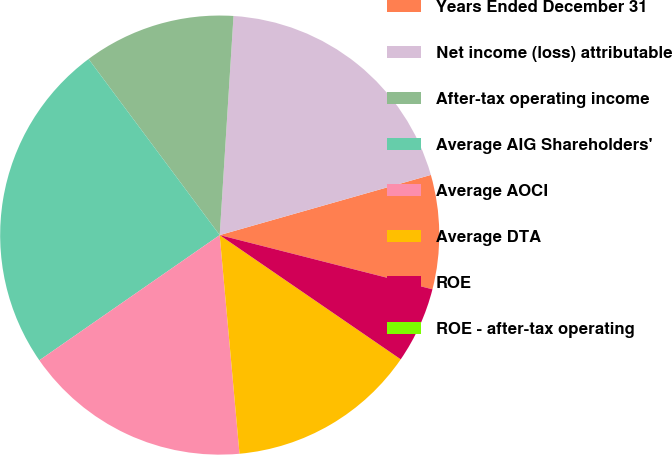<chart> <loc_0><loc_0><loc_500><loc_500><pie_chart><fcel>Years Ended December 31<fcel>Net income (loss) attributable<fcel>After-tax operating income<fcel>Average AIG Shareholders'<fcel>Average AOCI<fcel>Average DTA<fcel>ROE<fcel>ROE - after-tax operating<nl><fcel>8.39%<fcel>19.58%<fcel>11.19%<fcel>24.47%<fcel>16.78%<fcel>13.99%<fcel>5.6%<fcel>0.0%<nl></chart> 